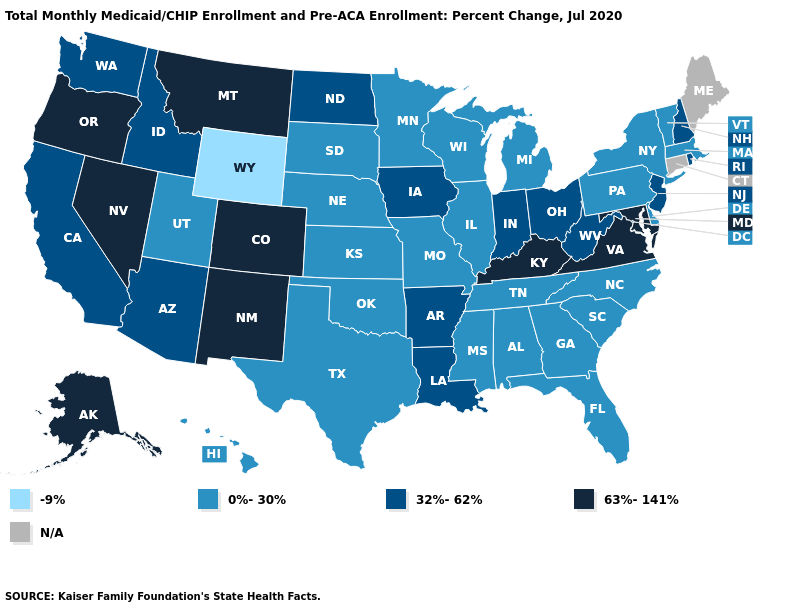Does the map have missing data?
Be succinct. Yes. How many symbols are there in the legend?
Quick response, please. 5. What is the value of Tennessee?
Be succinct. 0%-30%. Name the states that have a value in the range 63%-141%?
Short answer required. Alaska, Colorado, Kentucky, Maryland, Montana, Nevada, New Mexico, Oregon, Virginia. What is the value of Iowa?
Give a very brief answer. 32%-62%. What is the value of Minnesota?
Give a very brief answer. 0%-30%. Name the states that have a value in the range 0%-30%?
Write a very short answer. Alabama, Delaware, Florida, Georgia, Hawaii, Illinois, Kansas, Massachusetts, Michigan, Minnesota, Mississippi, Missouri, Nebraska, New York, North Carolina, Oklahoma, Pennsylvania, South Carolina, South Dakota, Tennessee, Texas, Utah, Vermont, Wisconsin. What is the highest value in the USA?
Answer briefly. 63%-141%. Which states have the lowest value in the Northeast?
Quick response, please. Massachusetts, New York, Pennsylvania, Vermont. Is the legend a continuous bar?
Keep it brief. No. Among the states that border Utah , does Idaho have the lowest value?
Keep it brief. No. Which states have the lowest value in the USA?
Concise answer only. Wyoming. Which states hav the highest value in the Northeast?
Keep it brief. New Hampshire, New Jersey, Rhode Island. 